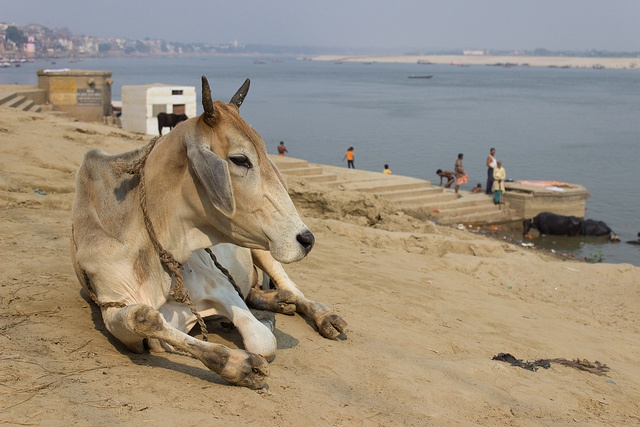Describe the objects in this image and their specific colors. I can see cow in darkgray, tan, and gray tones, cow in darkgray, black, gray, and tan tones, cow in darkgray, black, gray, and purple tones, cow in darkgray, black, and gray tones, and people in darkgray, black, and gray tones in this image. 